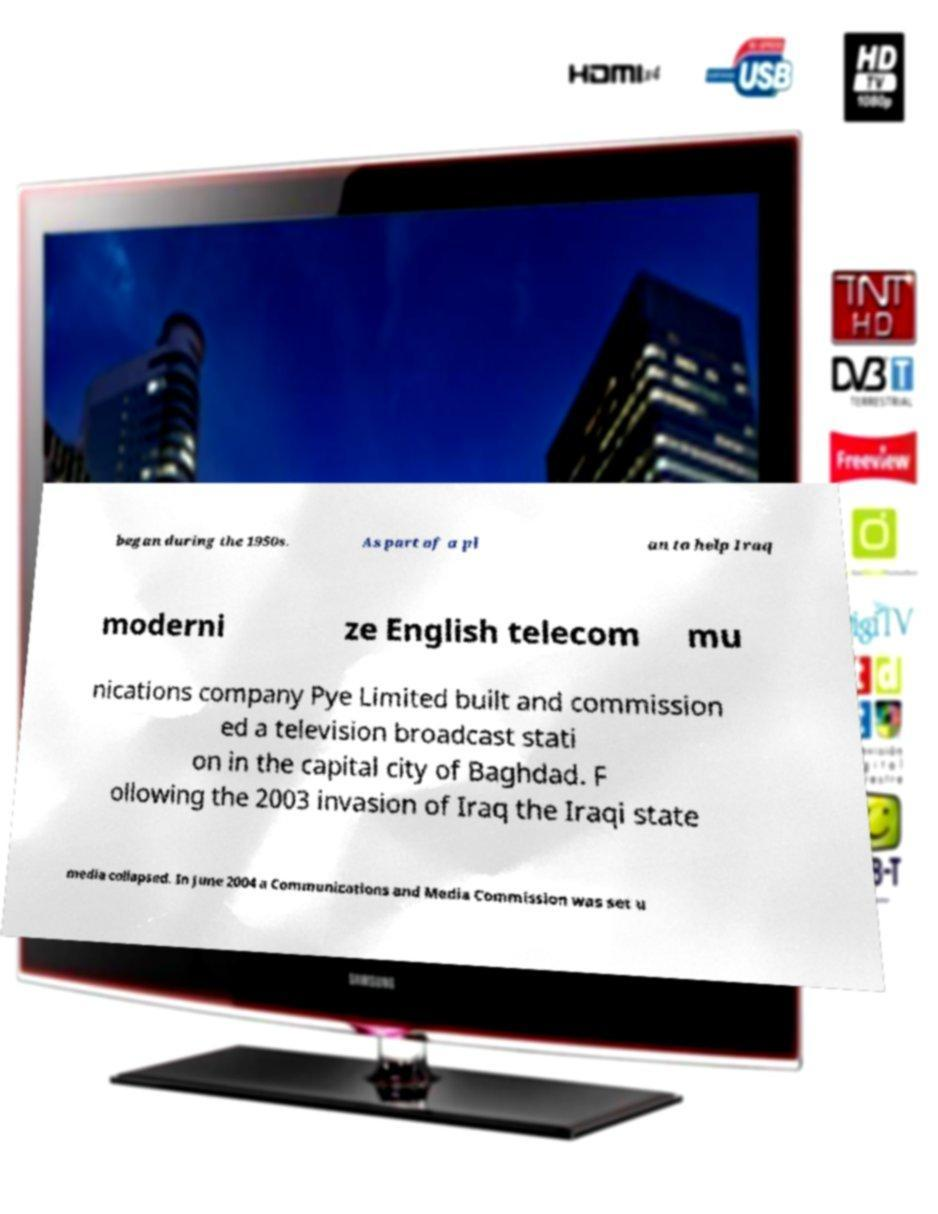Please read and relay the text visible in this image. What does it say? began during the 1950s. As part of a pl an to help Iraq moderni ze English telecom mu nications company Pye Limited built and commission ed a television broadcast stati on in the capital city of Baghdad. F ollowing the 2003 invasion of Iraq the Iraqi state media collapsed. In June 2004 a Communications and Media Commission was set u 